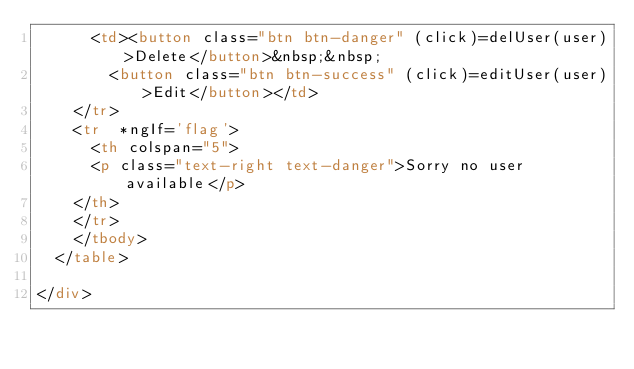Convert code to text. <code><loc_0><loc_0><loc_500><loc_500><_HTML_>      <td><button class="btn btn-danger" (click)=delUser(user)>Delete</button>&nbsp;&nbsp;
        <button class="btn btn-success" (click)=editUser(user)>Edit</button></td>
    </tr>
    <tr  *ngIf='flag'>
      <th colspan="5">
      <p class="text-right text-danger">Sorry no user available</p>
    </th>
    </tr>
    </tbody>
  </table>

</div>
</code> 